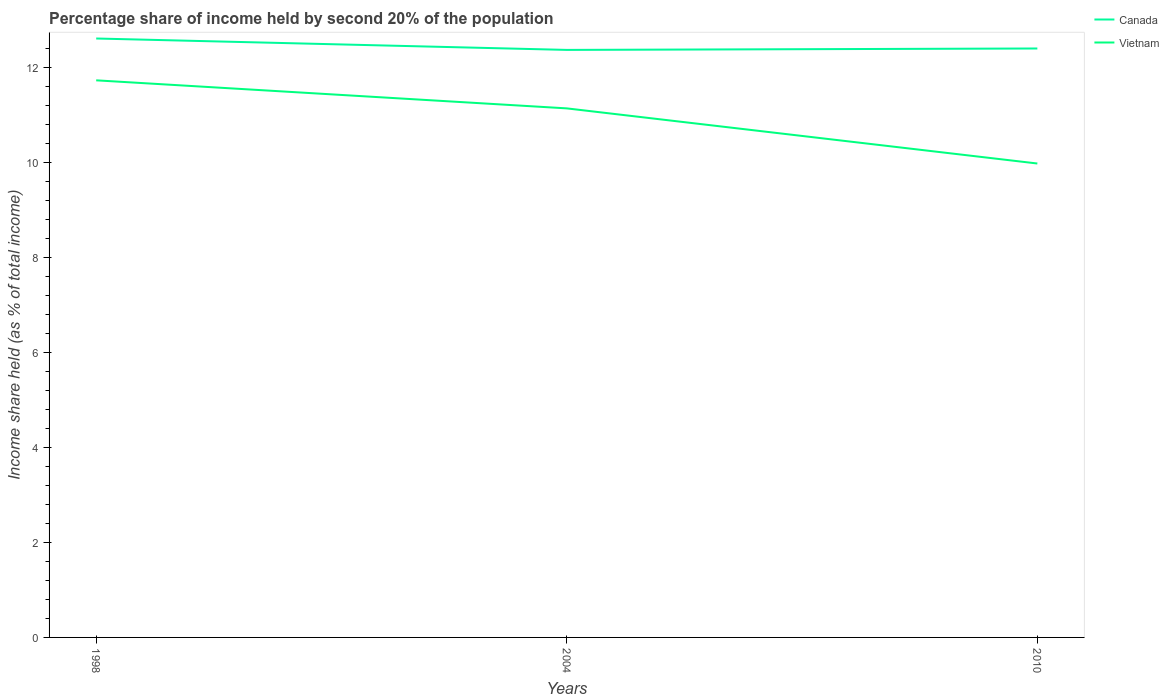Does the line corresponding to Canada intersect with the line corresponding to Vietnam?
Give a very brief answer. No. Across all years, what is the maximum share of income held by second 20% of the population in Canada?
Offer a terse response. 12.36. In which year was the share of income held by second 20% of the population in Canada maximum?
Keep it short and to the point. 2004. What is the total share of income held by second 20% of the population in Canada in the graph?
Your response must be concise. 0.21. What is the difference between the highest and the second highest share of income held by second 20% of the population in Vietnam?
Your answer should be very brief. 1.75. What is the difference between the highest and the lowest share of income held by second 20% of the population in Canada?
Your response must be concise. 1. How many lines are there?
Your answer should be very brief. 2. How many years are there in the graph?
Your answer should be very brief. 3. What is the difference between two consecutive major ticks on the Y-axis?
Make the answer very short. 2. Does the graph contain grids?
Offer a terse response. No. How are the legend labels stacked?
Offer a terse response. Vertical. What is the title of the graph?
Your response must be concise. Percentage share of income held by second 20% of the population. Does "Rwanda" appear as one of the legend labels in the graph?
Your answer should be very brief. No. What is the label or title of the X-axis?
Provide a short and direct response. Years. What is the label or title of the Y-axis?
Your answer should be compact. Income share held (as % of total income). What is the Income share held (as % of total income) of Vietnam in 1998?
Your response must be concise. 11.72. What is the Income share held (as % of total income) of Canada in 2004?
Make the answer very short. 12.36. What is the Income share held (as % of total income) in Vietnam in 2004?
Your answer should be compact. 11.13. What is the Income share held (as % of total income) in Canada in 2010?
Provide a succinct answer. 12.39. What is the Income share held (as % of total income) in Vietnam in 2010?
Ensure brevity in your answer.  9.97. Across all years, what is the maximum Income share held (as % of total income) in Canada?
Your response must be concise. 12.6. Across all years, what is the maximum Income share held (as % of total income) of Vietnam?
Make the answer very short. 11.72. Across all years, what is the minimum Income share held (as % of total income) in Canada?
Your answer should be very brief. 12.36. Across all years, what is the minimum Income share held (as % of total income) of Vietnam?
Provide a short and direct response. 9.97. What is the total Income share held (as % of total income) in Canada in the graph?
Your answer should be very brief. 37.35. What is the total Income share held (as % of total income) of Vietnam in the graph?
Give a very brief answer. 32.82. What is the difference between the Income share held (as % of total income) of Canada in 1998 and that in 2004?
Give a very brief answer. 0.24. What is the difference between the Income share held (as % of total income) of Vietnam in 1998 and that in 2004?
Ensure brevity in your answer.  0.59. What is the difference between the Income share held (as % of total income) in Canada in 1998 and that in 2010?
Your answer should be compact. 0.21. What is the difference between the Income share held (as % of total income) of Vietnam in 1998 and that in 2010?
Provide a short and direct response. 1.75. What is the difference between the Income share held (as % of total income) in Canada in 2004 and that in 2010?
Your response must be concise. -0.03. What is the difference between the Income share held (as % of total income) of Vietnam in 2004 and that in 2010?
Provide a succinct answer. 1.16. What is the difference between the Income share held (as % of total income) in Canada in 1998 and the Income share held (as % of total income) in Vietnam in 2004?
Provide a succinct answer. 1.47. What is the difference between the Income share held (as % of total income) of Canada in 1998 and the Income share held (as % of total income) of Vietnam in 2010?
Provide a short and direct response. 2.63. What is the difference between the Income share held (as % of total income) of Canada in 2004 and the Income share held (as % of total income) of Vietnam in 2010?
Your answer should be very brief. 2.39. What is the average Income share held (as % of total income) of Canada per year?
Your response must be concise. 12.45. What is the average Income share held (as % of total income) in Vietnam per year?
Offer a terse response. 10.94. In the year 1998, what is the difference between the Income share held (as % of total income) in Canada and Income share held (as % of total income) in Vietnam?
Provide a succinct answer. 0.88. In the year 2004, what is the difference between the Income share held (as % of total income) in Canada and Income share held (as % of total income) in Vietnam?
Provide a short and direct response. 1.23. In the year 2010, what is the difference between the Income share held (as % of total income) in Canada and Income share held (as % of total income) in Vietnam?
Your answer should be compact. 2.42. What is the ratio of the Income share held (as % of total income) in Canada in 1998 to that in 2004?
Make the answer very short. 1.02. What is the ratio of the Income share held (as % of total income) of Vietnam in 1998 to that in 2004?
Offer a terse response. 1.05. What is the ratio of the Income share held (as % of total income) of Canada in 1998 to that in 2010?
Offer a very short reply. 1.02. What is the ratio of the Income share held (as % of total income) in Vietnam in 1998 to that in 2010?
Your answer should be very brief. 1.18. What is the ratio of the Income share held (as % of total income) in Canada in 2004 to that in 2010?
Provide a succinct answer. 1. What is the ratio of the Income share held (as % of total income) of Vietnam in 2004 to that in 2010?
Provide a short and direct response. 1.12. What is the difference between the highest and the second highest Income share held (as % of total income) of Canada?
Offer a very short reply. 0.21. What is the difference between the highest and the second highest Income share held (as % of total income) in Vietnam?
Your response must be concise. 0.59. What is the difference between the highest and the lowest Income share held (as % of total income) of Canada?
Provide a short and direct response. 0.24. 